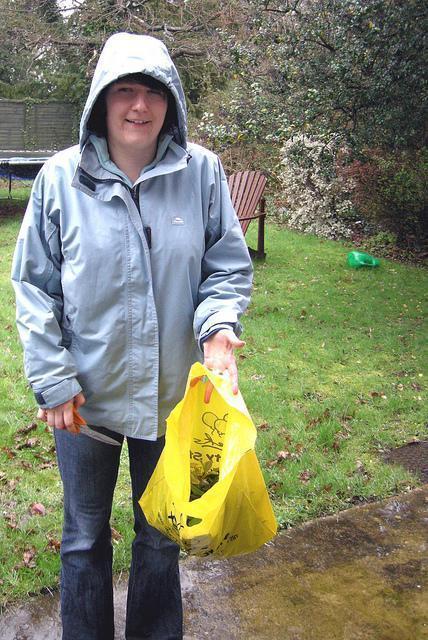What was probably stored in the container on the grass?
Answer the question by selecting the correct answer among the 4 following choices and explain your choice with a short sentence. The answer should be formatted with the following format: `Answer: choice
Rationale: rationale.`
Options: Detergent, marbles, rice, cake. Answer: detergent.
Rationale: The container is a detergent container. 